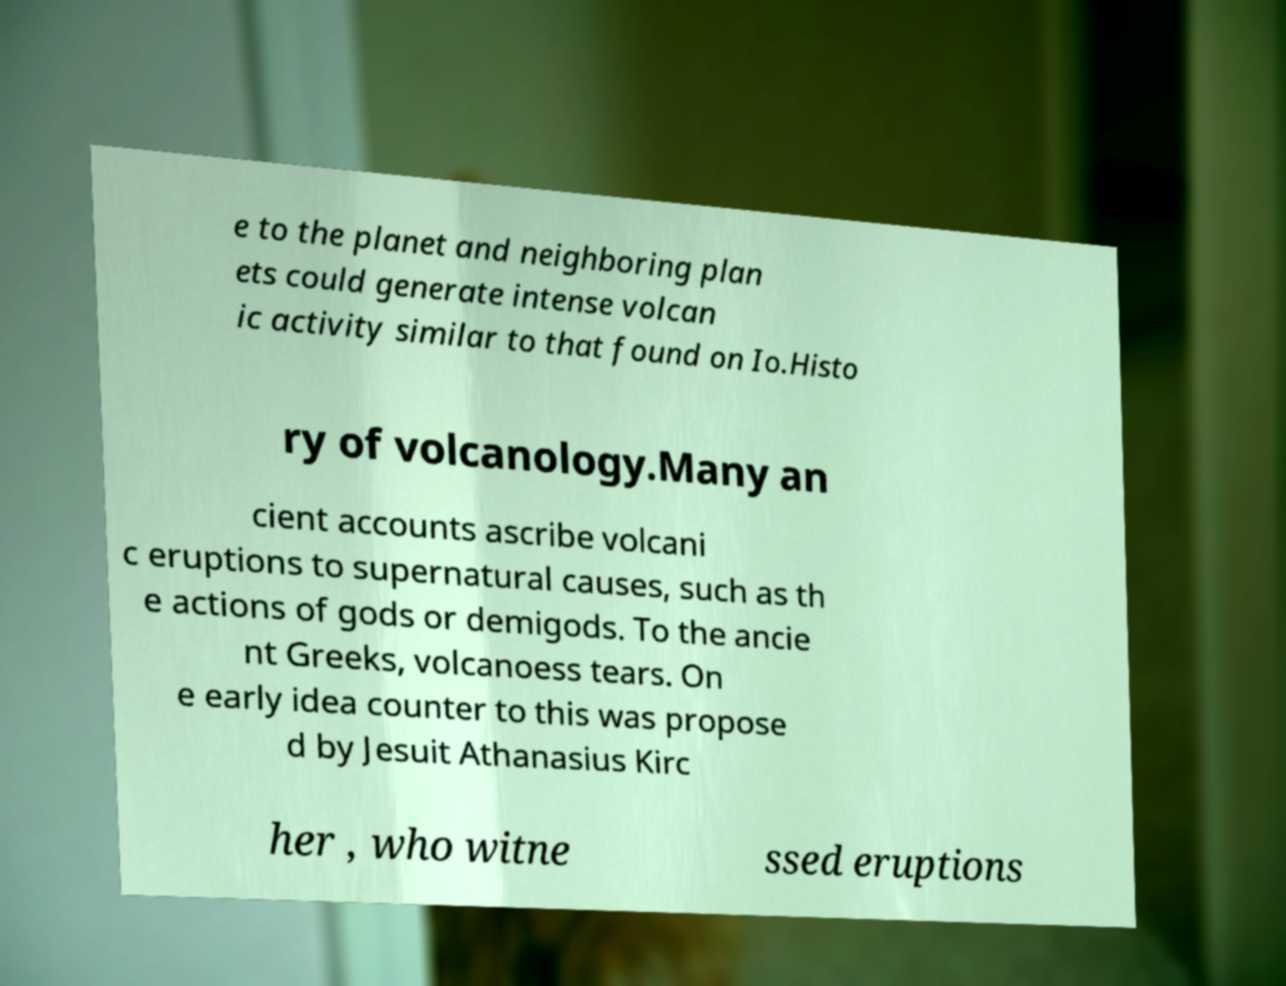Please identify and transcribe the text found in this image. e to the planet and neighboring plan ets could generate intense volcan ic activity similar to that found on Io.Histo ry of volcanology.Many an cient accounts ascribe volcani c eruptions to supernatural causes, such as th e actions of gods or demigods. To the ancie nt Greeks, volcanoess tears. On e early idea counter to this was propose d by Jesuit Athanasius Kirc her , who witne ssed eruptions 